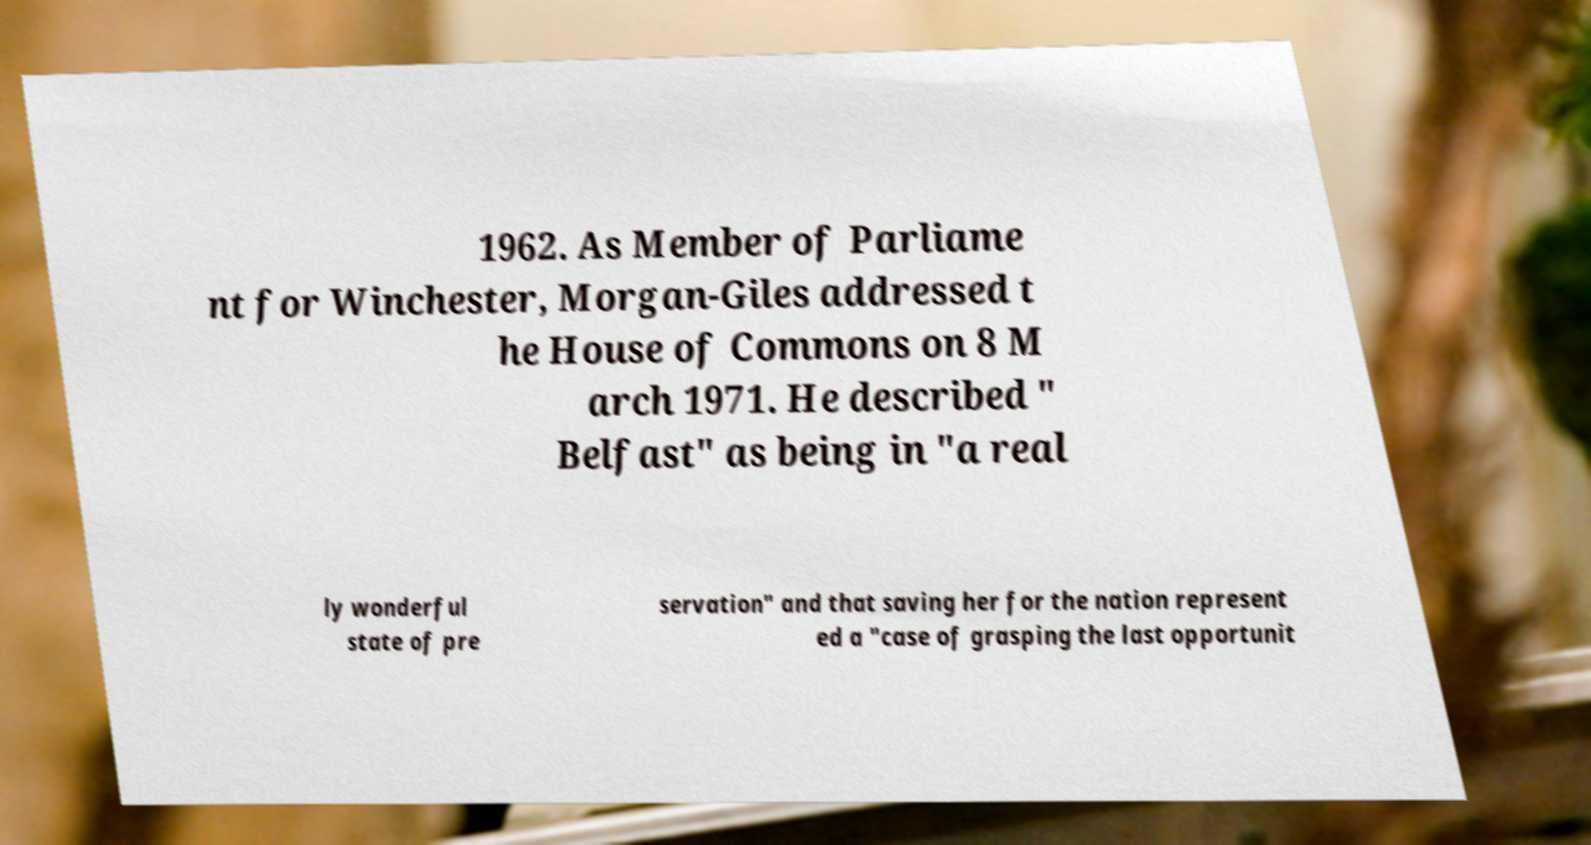Can you read and provide the text displayed in the image?This photo seems to have some interesting text. Can you extract and type it out for me? 1962. As Member of Parliame nt for Winchester, Morgan-Giles addressed t he House of Commons on 8 M arch 1971. He described " Belfast" as being in "a real ly wonderful state of pre servation" and that saving her for the nation represent ed a "case of grasping the last opportunit 